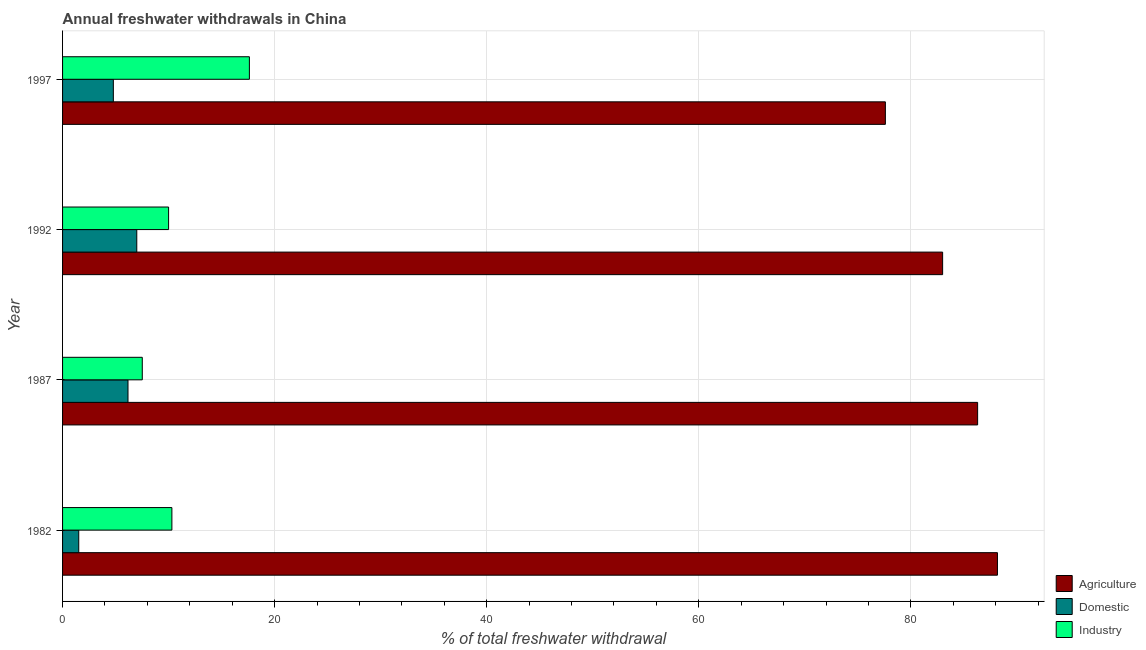How many groups of bars are there?
Provide a short and direct response. 4. Are the number of bars per tick equal to the number of legend labels?
Provide a short and direct response. Yes. Are the number of bars on each tick of the Y-axis equal?
Ensure brevity in your answer.  Yes. How many bars are there on the 2nd tick from the top?
Provide a succinct answer. 3. In how many cases, is the number of bars for a given year not equal to the number of legend labels?
Make the answer very short. 0. What is the percentage of freshwater withdrawal for industry in 1997?
Provide a short and direct response. 17.62. Across all years, what is the minimum percentage of freshwater withdrawal for domestic purposes?
Offer a very short reply. 1.53. In which year was the percentage of freshwater withdrawal for industry minimum?
Keep it short and to the point. 1987. What is the total percentage of freshwater withdrawal for domestic purposes in the graph?
Offer a very short reply. 19.49. What is the difference between the percentage of freshwater withdrawal for industry in 1982 and that in 1987?
Provide a succinct answer. 2.79. What is the difference between the percentage of freshwater withdrawal for industry in 1992 and the percentage of freshwater withdrawal for agriculture in 1997?
Give a very brief answer. -67.6. What is the average percentage of freshwater withdrawal for domestic purposes per year?
Your answer should be compact. 4.87. In the year 1997, what is the difference between the percentage of freshwater withdrawal for agriculture and percentage of freshwater withdrawal for domestic purposes?
Keep it short and to the point. 72.81. In how many years, is the percentage of freshwater withdrawal for domestic purposes greater than 60 %?
Your response must be concise. 0. What is the ratio of the percentage of freshwater withdrawal for domestic purposes in 1987 to that in 1992?
Your answer should be compact. 0.88. Is the percentage of freshwater withdrawal for agriculture in 1992 less than that in 1997?
Your answer should be very brief. No. What is the difference between the highest and the second highest percentage of freshwater withdrawal for industry?
Keep it short and to the point. 7.31. What is the difference between the highest and the lowest percentage of freshwater withdrawal for industry?
Make the answer very short. 10.1. In how many years, is the percentage of freshwater withdrawal for industry greater than the average percentage of freshwater withdrawal for industry taken over all years?
Provide a succinct answer. 1. Is the sum of the percentage of freshwater withdrawal for industry in 1982 and 1987 greater than the maximum percentage of freshwater withdrawal for domestic purposes across all years?
Keep it short and to the point. Yes. What does the 2nd bar from the top in 1982 represents?
Your answer should be compact. Domestic. What does the 2nd bar from the bottom in 1982 represents?
Ensure brevity in your answer.  Domestic. How many bars are there?
Provide a succinct answer. 12. Are all the bars in the graph horizontal?
Your answer should be very brief. Yes. How many years are there in the graph?
Offer a terse response. 4. Does the graph contain grids?
Offer a terse response. Yes. Where does the legend appear in the graph?
Your answer should be compact. Bottom right. How many legend labels are there?
Ensure brevity in your answer.  3. What is the title of the graph?
Provide a succinct answer. Annual freshwater withdrawals in China. What is the label or title of the X-axis?
Offer a terse response. % of total freshwater withdrawal. What is the % of total freshwater withdrawal of Agriculture in 1982?
Provide a succinct answer. 88.17. What is the % of total freshwater withdrawal of Domestic in 1982?
Offer a very short reply. 1.53. What is the % of total freshwater withdrawal in Industry in 1982?
Offer a terse response. 10.31. What is the % of total freshwater withdrawal of Agriculture in 1987?
Provide a short and direct response. 86.3. What is the % of total freshwater withdrawal of Domestic in 1987?
Give a very brief answer. 6.17. What is the % of total freshwater withdrawal in Industry in 1987?
Your response must be concise. 7.52. What is the % of total freshwater withdrawal in Agriculture in 1992?
Provide a succinct answer. 83. What is the % of total freshwater withdrawal of Domestic in 1992?
Keep it short and to the point. 7. What is the % of total freshwater withdrawal in Agriculture in 1997?
Your answer should be very brief. 77.6. What is the % of total freshwater withdrawal in Domestic in 1997?
Keep it short and to the point. 4.79. What is the % of total freshwater withdrawal of Industry in 1997?
Your answer should be very brief. 17.62. Across all years, what is the maximum % of total freshwater withdrawal in Agriculture?
Provide a short and direct response. 88.17. Across all years, what is the maximum % of total freshwater withdrawal in Domestic?
Offer a terse response. 7. Across all years, what is the maximum % of total freshwater withdrawal of Industry?
Keep it short and to the point. 17.62. Across all years, what is the minimum % of total freshwater withdrawal of Agriculture?
Give a very brief answer. 77.6. Across all years, what is the minimum % of total freshwater withdrawal of Domestic?
Your answer should be very brief. 1.53. Across all years, what is the minimum % of total freshwater withdrawal of Industry?
Your response must be concise. 7.52. What is the total % of total freshwater withdrawal of Agriculture in the graph?
Make the answer very short. 335.07. What is the total % of total freshwater withdrawal of Domestic in the graph?
Provide a succinct answer. 19.49. What is the total % of total freshwater withdrawal in Industry in the graph?
Offer a very short reply. 45.45. What is the difference between the % of total freshwater withdrawal of Agriculture in 1982 and that in 1987?
Make the answer very short. 1.87. What is the difference between the % of total freshwater withdrawal in Domestic in 1982 and that in 1987?
Provide a succinct answer. -4.64. What is the difference between the % of total freshwater withdrawal in Industry in 1982 and that in 1987?
Your answer should be compact. 2.79. What is the difference between the % of total freshwater withdrawal of Agriculture in 1982 and that in 1992?
Offer a very short reply. 5.17. What is the difference between the % of total freshwater withdrawal of Domestic in 1982 and that in 1992?
Your response must be concise. -5.47. What is the difference between the % of total freshwater withdrawal in Industry in 1982 and that in 1992?
Your answer should be compact. 0.31. What is the difference between the % of total freshwater withdrawal of Agriculture in 1982 and that in 1997?
Offer a very short reply. 10.57. What is the difference between the % of total freshwater withdrawal in Domestic in 1982 and that in 1997?
Keep it short and to the point. -3.26. What is the difference between the % of total freshwater withdrawal in Industry in 1982 and that in 1997?
Your answer should be compact. -7.31. What is the difference between the % of total freshwater withdrawal of Agriculture in 1987 and that in 1992?
Keep it short and to the point. 3.3. What is the difference between the % of total freshwater withdrawal in Domestic in 1987 and that in 1992?
Make the answer very short. -0.83. What is the difference between the % of total freshwater withdrawal of Industry in 1987 and that in 1992?
Your answer should be compact. -2.48. What is the difference between the % of total freshwater withdrawal in Agriculture in 1987 and that in 1997?
Your answer should be very brief. 8.7. What is the difference between the % of total freshwater withdrawal of Domestic in 1987 and that in 1997?
Offer a very short reply. 1.38. What is the difference between the % of total freshwater withdrawal in Industry in 1987 and that in 1997?
Keep it short and to the point. -10.1. What is the difference between the % of total freshwater withdrawal in Domestic in 1992 and that in 1997?
Offer a terse response. 2.21. What is the difference between the % of total freshwater withdrawal of Industry in 1992 and that in 1997?
Provide a short and direct response. -7.62. What is the difference between the % of total freshwater withdrawal in Agriculture in 1982 and the % of total freshwater withdrawal in Domestic in 1987?
Your answer should be compact. 82. What is the difference between the % of total freshwater withdrawal of Agriculture in 1982 and the % of total freshwater withdrawal of Industry in 1987?
Your answer should be very brief. 80.65. What is the difference between the % of total freshwater withdrawal of Domestic in 1982 and the % of total freshwater withdrawal of Industry in 1987?
Keep it short and to the point. -5.99. What is the difference between the % of total freshwater withdrawal in Agriculture in 1982 and the % of total freshwater withdrawal in Domestic in 1992?
Your answer should be very brief. 81.17. What is the difference between the % of total freshwater withdrawal in Agriculture in 1982 and the % of total freshwater withdrawal in Industry in 1992?
Offer a terse response. 78.17. What is the difference between the % of total freshwater withdrawal of Domestic in 1982 and the % of total freshwater withdrawal of Industry in 1992?
Provide a short and direct response. -8.47. What is the difference between the % of total freshwater withdrawal in Agriculture in 1982 and the % of total freshwater withdrawal in Domestic in 1997?
Keep it short and to the point. 83.38. What is the difference between the % of total freshwater withdrawal of Agriculture in 1982 and the % of total freshwater withdrawal of Industry in 1997?
Provide a short and direct response. 70.55. What is the difference between the % of total freshwater withdrawal of Domestic in 1982 and the % of total freshwater withdrawal of Industry in 1997?
Provide a succinct answer. -16.09. What is the difference between the % of total freshwater withdrawal in Agriculture in 1987 and the % of total freshwater withdrawal in Domestic in 1992?
Your response must be concise. 79.3. What is the difference between the % of total freshwater withdrawal in Agriculture in 1987 and the % of total freshwater withdrawal in Industry in 1992?
Your response must be concise. 76.3. What is the difference between the % of total freshwater withdrawal of Domestic in 1987 and the % of total freshwater withdrawal of Industry in 1992?
Give a very brief answer. -3.83. What is the difference between the % of total freshwater withdrawal of Agriculture in 1987 and the % of total freshwater withdrawal of Domestic in 1997?
Your answer should be compact. 81.51. What is the difference between the % of total freshwater withdrawal in Agriculture in 1987 and the % of total freshwater withdrawal in Industry in 1997?
Make the answer very short. 68.68. What is the difference between the % of total freshwater withdrawal of Domestic in 1987 and the % of total freshwater withdrawal of Industry in 1997?
Give a very brief answer. -11.45. What is the difference between the % of total freshwater withdrawal of Agriculture in 1992 and the % of total freshwater withdrawal of Domestic in 1997?
Provide a short and direct response. 78.21. What is the difference between the % of total freshwater withdrawal of Agriculture in 1992 and the % of total freshwater withdrawal of Industry in 1997?
Your answer should be compact. 65.38. What is the difference between the % of total freshwater withdrawal of Domestic in 1992 and the % of total freshwater withdrawal of Industry in 1997?
Your response must be concise. -10.62. What is the average % of total freshwater withdrawal in Agriculture per year?
Your answer should be very brief. 83.77. What is the average % of total freshwater withdrawal of Domestic per year?
Your response must be concise. 4.87. What is the average % of total freshwater withdrawal of Industry per year?
Offer a terse response. 11.36. In the year 1982, what is the difference between the % of total freshwater withdrawal of Agriculture and % of total freshwater withdrawal of Domestic?
Offer a terse response. 86.64. In the year 1982, what is the difference between the % of total freshwater withdrawal of Agriculture and % of total freshwater withdrawal of Industry?
Ensure brevity in your answer.  77.86. In the year 1982, what is the difference between the % of total freshwater withdrawal of Domestic and % of total freshwater withdrawal of Industry?
Your answer should be compact. -8.78. In the year 1987, what is the difference between the % of total freshwater withdrawal in Agriculture and % of total freshwater withdrawal in Domestic?
Your response must be concise. 80.13. In the year 1987, what is the difference between the % of total freshwater withdrawal of Agriculture and % of total freshwater withdrawal of Industry?
Your answer should be very brief. 78.78. In the year 1987, what is the difference between the % of total freshwater withdrawal in Domestic and % of total freshwater withdrawal in Industry?
Offer a terse response. -1.35. In the year 1997, what is the difference between the % of total freshwater withdrawal in Agriculture and % of total freshwater withdrawal in Domestic?
Make the answer very short. 72.81. In the year 1997, what is the difference between the % of total freshwater withdrawal of Agriculture and % of total freshwater withdrawal of Industry?
Provide a short and direct response. 59.98. In the year 1997, what is the difference between the % of total freshwater withdrawal of Domestic and % of total freshwater withdrawal of Industry?
Offer a terse response. -12.83. What is the ratio of the % of total freshwater withdrawal of Agriculture in 1982 to that in 1987?
Provide a succinct answer. 1.02. What is the ratio of the % of total freshwater withdrawal in Domestic in 1982 to that in 1987?
Make the answer very short. 0.25. What is the ratio of the % of total freshwater withdrawal of Industry in 1982 to that in 1987?
Give a very brief answer. 1.37. What is the ratio of the % of total freshwater withdrawal in Agriculture in 1982 to that in 1992?
Provide a succinct answer. 1.06. What is the ratio of the % of total freshwater withdrawal of Domestic in 1982 to that in 1992?
Offer a terse response. 0.22. What is the ratio of the % of total freshwater withdrawal of Industry in 1982 to that in 1992?
Make the answer very short. 1.03. What is the ratio of the % of total freshwater withdrawal in Agriculture in 1982 to that in 1997?
Provide a short and direct response. 1.14. What is the ratio of the % of total freshwater withdrawal of Domestic in 1982 to that in 1997?
Your answer should be very brief. 0.32. What is the ratio of the % of total freshwater withdrawal in Industry in 1982 to that in 1997?
Keep it short and to the point. 0.59. What is the ratio of the % of total freshwater withdrawal in Agriculture in 1987 to that in 1992?
Keep it short and to the point. 1.04. What is the ratio of the % of total freshwater withdrawal in Domestic in 1987 to that in 1992?
Your response must be concise. 0.88. What is the ratio of the % of total freshwater withdrawal of Industry in 1987 to that in 1992?
Your response must be concise. 0.75. What is the ratio of the % of total freshwater withdrawal in Agriculture in 1987 to that in 1997?
Offer a terse response. 1.11. What is the ratio of the % of total freshwater withdrawal of Domestic in 1987 to that in 1997?
Keep it short and to the point. 1.29. What is the ratio of the % of total freshwater withdrawal of Industry in 1987 to that in 1997?
Offer a terse response. 0.43. What is the ratio of the % of total freshwater withdrawal in Agriculture in 1992 to that in 1997?
Provide a short and direct response. 1.07. What is the ratio of the % of total freshwater withdrawal of Domestic in 1992 to that in 1997?
Keep it short and to the point. 1.46. What is the ratio of the % of total freshwater withdrawal of Industry in 1992 to that in 1997?
Your answer should be compact. 0.57. What is the difference between the highest and the second highest % of total freshwater withdrawal in Agriculture?
Give a very brief answer. 1.87. What is the difference between the highest and the second highest % of total freshwater withdrawal in Domestic?
Make the answer very short. 0.83. What is the difference between the highest and the second highest % of total freshwater withdrawal of Industry?
Give a very brief answer. 7.31. What is the difference between the highest and the lowest % of total freshwater withdrawal of Agriculture?
Provide a short and direct response. 10.57. What is the difference between the highest and the lowest % of total freshwater withdrawal of Domestic?
Keep it short and to the point. 5.47. What is the difference between the highest and the lowest % of total freshwater withdrawal of Industry?
Make the answer very short. 10.1. 